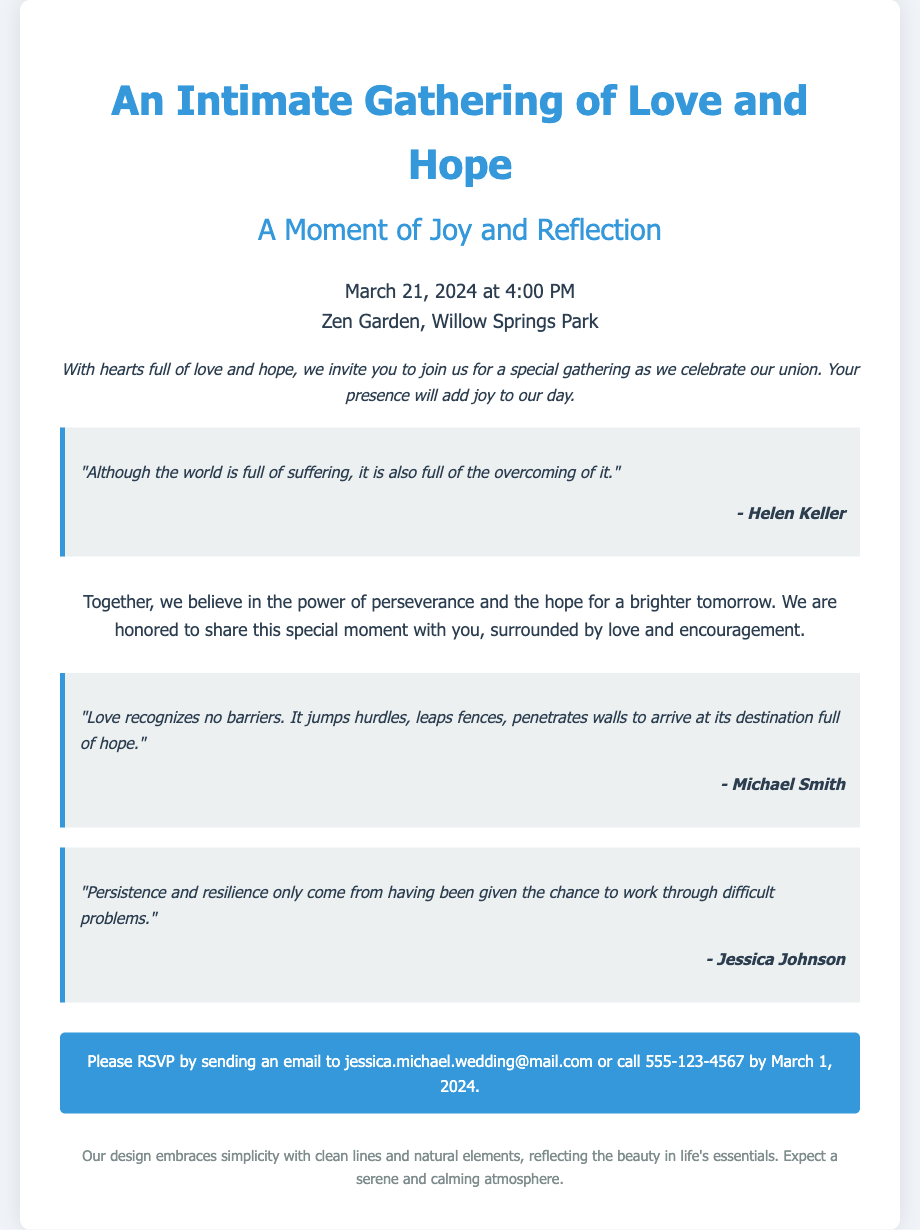What is the date of the wedding? The date of the wedding is specified in the document as "March 21, 2024."
Answer: March 21, 2024 What time is the wedding scheduled? The time of the wedding is mentioned in the document, which states "4:00 PM."
Answer: 4:00 PM Where is the wedding taking place? The location of the wedding is given as "Zen Garden, Willow Springs Park."
Answer: Zen Garden, Willow Springs Park Who are the hosts of the event? The document mentions the hosts as "Jessica and Michael."
Answer: Jessica and Michael What is the RSVP deadline? The RSVP deadline is stated as "March 1, 2024."
Answer: March 1, 2024 What is one of the quotes mentioned in the invitation? The document includes a quote by Helen Keller: "Although the world is full of suffering, it is also full of the overcoming of it."
Answer: "Although the world is full of suffering, it is also full of the overcoming of it." What theme does the invitation embrace? The invitation emphasizes a design theme of "simplicity with clean lines and natural elements."
Answer: simplicity with clean lines and natural elements What is the purpose of the gathering? The document specifies the gathering as "a special gathering as we celebrate our union."
Answer: a special gathering as we celebrate our union How can attendees RSVP? The invitation provides an email and phone number for RSVPs: "jessica.michael.wedding@mail.com or call 555-123-4567."
Answer: jessica.michael.wedding@mail.com or call 555-123-4567 